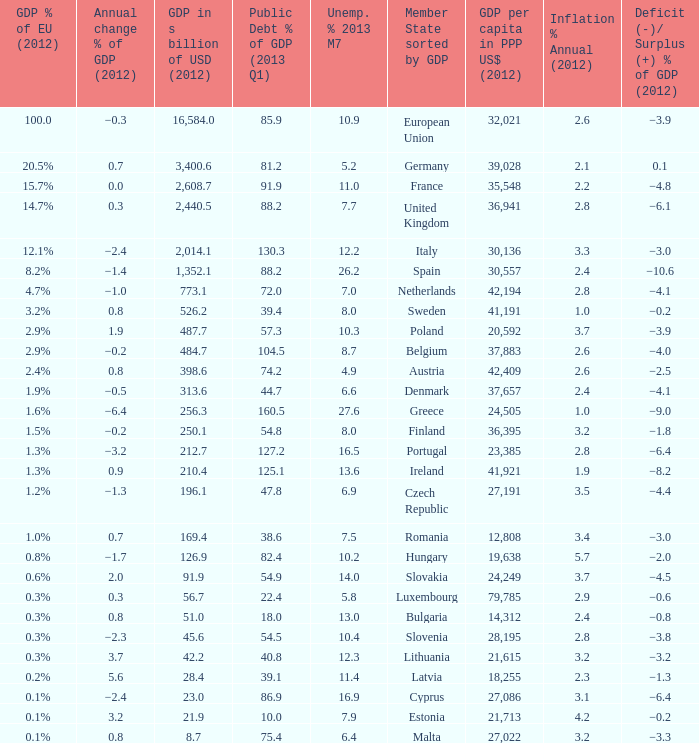What is the deficit/surplus % of the 2012 GDP of the country with a GDP in billions of USD in 2012 less than 1,352.1, a GDP per capita in PPP US dollars in 2012 greater than 21,615, public debt % of GDP in the 2013 Q1 less than 75.4, and an inflation % annual in 2012 of 2.9? −0.6. 